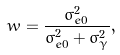Convert formula to latex. <formula><loc_0><loc_0><loc_500><loc_500>w = \frac { \sigma _ { e 0 } ^ { 2 } } { \sigma _ { e 0 } ^ { 2 } + \sigma _ { \gamma } ^ { 2 } } ,</formula> 